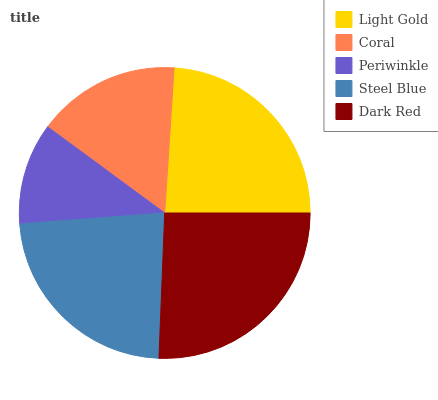Is Periwinkle the minimum?
Answer yes or no. Yes. Is Dark Red the maximum?
Answer yes or no. Yes. Is Coral the minimum?
Answer yes or no. No. Is Coral the maximum?
Answer yes or no. No. Is Light Gold greater than Coral?
Answer yes or no. Yes. Is Coral less than Light Gold?
Answer yes or no. Yes. Is Coral greater than Light Gold?
Answer yes or no. No. Is Light Gold less than Coral?
Answer yes or no. No. Is Steel Blue the high median?
Answer yes or no. Yes. Is Steel Blue the low median?
Answer yes or no. Yes. Is Dark Red the high median?
Answer yes or no. No. Is Periwinkle the low median?
Answer yes or no. No. 